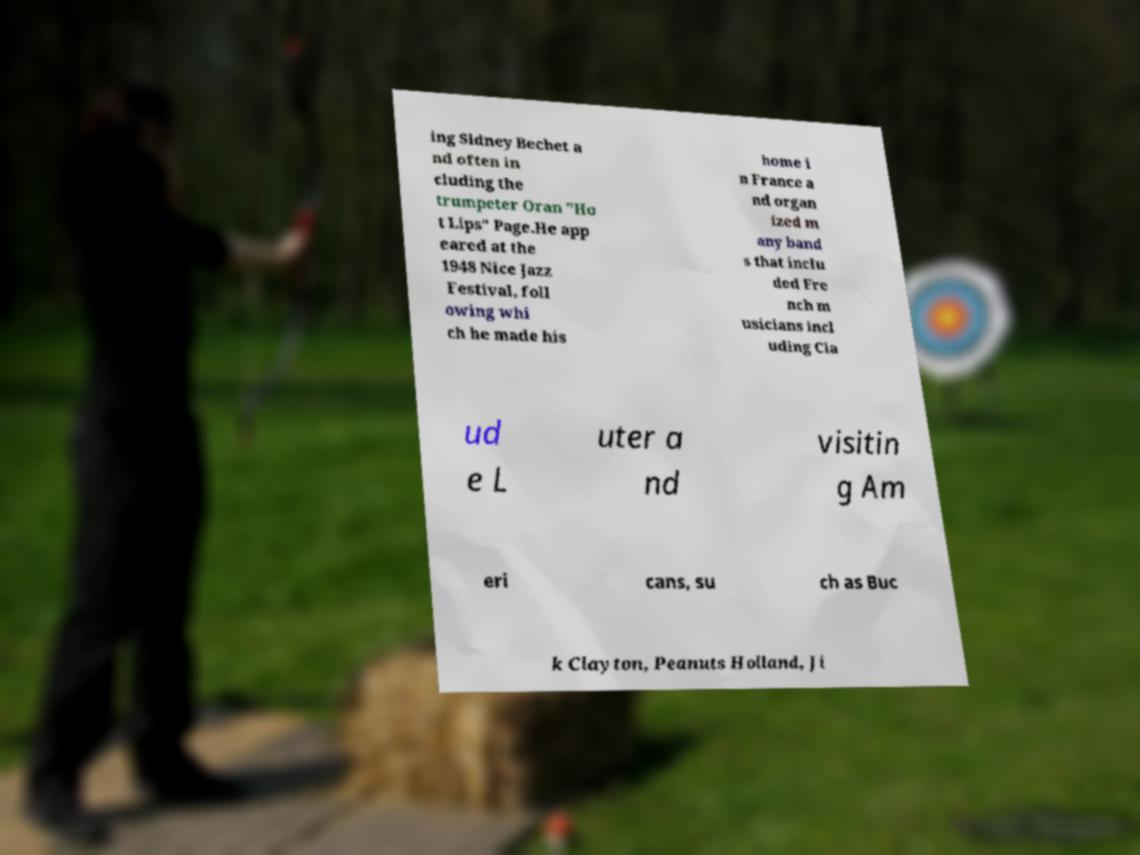Please read and relay the text visible in this image. What does it say? ing Sidney Bechet a nd often in cluding the trumpeter Oran "Ho t Lips" Page.He app eared at the 1948 Nice Jazz Festival, foll owing whi ch he made his home i n France a nd organ ized m any band s that inclu ded Fre nch m usicians incl uding Cla ud e L uter a nd visitin g Am eri cans, su ch as Buc k Clayton, Peanuts Holland, Ji 